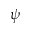<formula> <loc_0><loc_0><loc_500><loc_500>\psi</formula> 